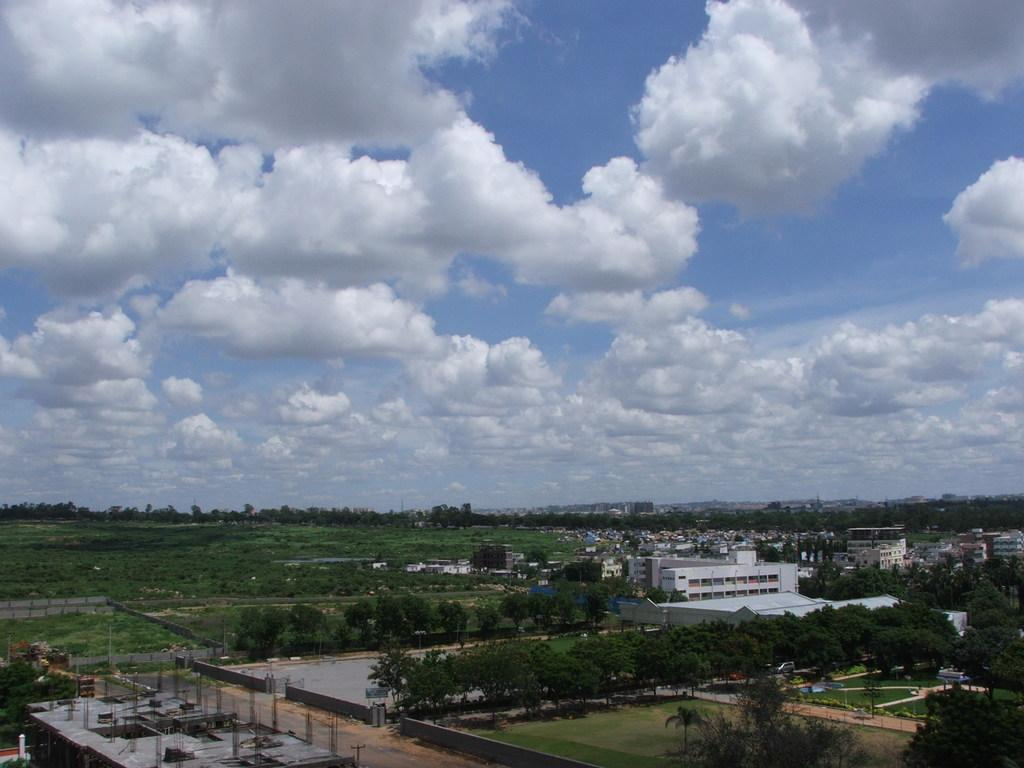What type of natural elements can be seen at the bottom of the image? There are trees at the bottom of the image. What type of man-made structures can be seen at the bottom of the image? There are buildings at the bottom of the image. What is visible at the top of the image? The sky is visible at the top of the image. What is the condition of the sky in the image? The sky is cloudy in the image. What type of acoustics can be heard in the image? There is no sound or acoustics present in the image, as it is a static visual representation. Can you tell me who the owner of the trees is in the image? There is no information about the ownership of the trees or any other elements in the image. 